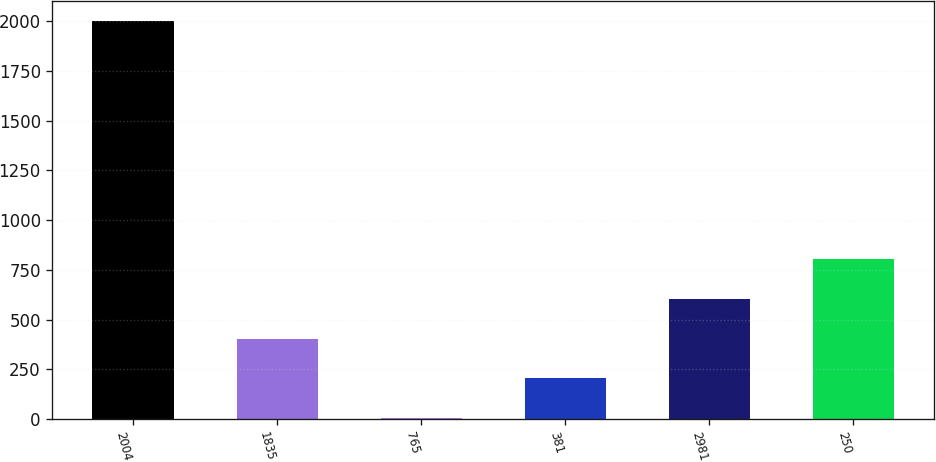Convert chart to OTSL. <chart><loc_0><loc_0><loc_500><loc_500><bar_chart><fcel>2004<fcel>1835<fcel>765<fcel>381<fcel>2981<fcel>250<nl><fcel>2002<fcel>403.76<fcel>4.2<fcel>203.98<fcel>603.54<fcel>803.32<nl></chart> 